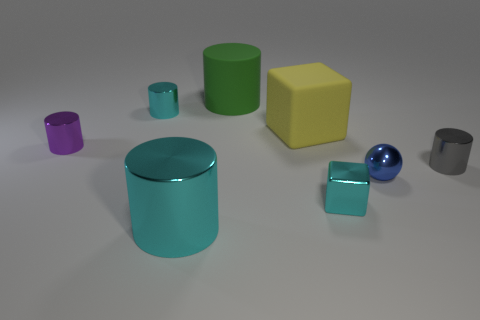Is the shape of the large metallic object the same as the gray shiny thing?
Keep it short and to the point. Yes. Are there an equal number of metallic cubes that are in front of the purple thing and small brown spheres?
Make the answer very short. No. What color is the other cylinder that is the same size as the rubber cylinder?
Offer a terse response. Cyan. Is there a blue object of the same shape as the yellow matte object?
Make the answer very short. No. What is the material of the small cylinder to the left of the cyan thing left of the shiny cylinder in front of the cyan cube?
Your answer should be very brief. Metal. How many other things are the same size as the yellow matte cube?
Ensure brevity in your answer.  2. The matte block has what color?
Provide a short and direct response. Yellow. What number of rubber objects are big yellow balls or small purple things?
Provide a short and direct response. 0. There is a metallic cylinder that is on the right side of the big green cylinder behind the small shiny cylinder that is on the right side of the big cyan cylinder; what is its size?
Your answer should be compact. Small. There is a cyan metal thing that is in front of the small gray cylinder and left of the yellow rubber cube; what size is it?
Provide a succinct answer. Large. 